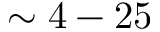Convert formula to latex. <formula><loc_0><loc_0><loc_500><loc_500>\sim 4 - 2 5</formula> 